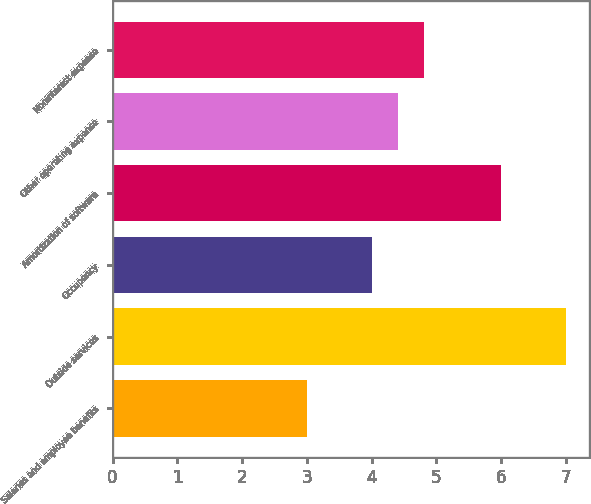Convert chart to OTSL. <chart><loc_0><loc_0><loc_500><loc_500><bar_chart><fcel>Salaries and employee benefits<fcel>Outside services<fcel>Occupancy<fcel>Amortization of software<fcel>Other operating expense<fcel>Noninterest expense<nl><fcel>3<fcel>7<fcel>4<fcel>6<fcel>4.4<fcel>4.8<nl></chart> 